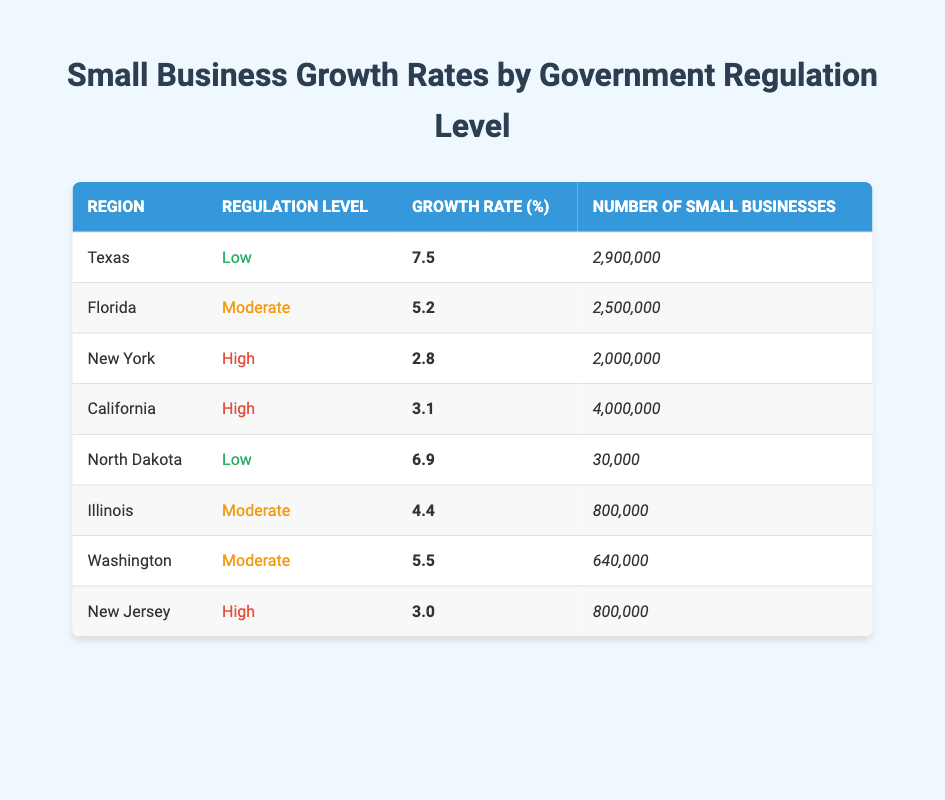What is the small business growth rate in Texas? According to the table, Texas has a small business growth rate of 7.5%. This value is explicitly stated in the row for Texas.
Answer: 7.5% Which region has the highest number of small businesses? By comparing the values in the "Number of Small Businesses" column, California has the highest number at 4,000,000.
Answer: California What is the average small business growth rate for regions with low government regulation? The growth rates for regions with low regulation are 7.5% (Texas) and 6.9% (North Dakota). To find the average, add these two values: 7.5 + 6.9 = 14.4%. Then, divide by 2 to find the average: 14.4 / 2 = 7.2%.
Answer: 7.2% Is the statement "Florida has a higher small business growth rate than New York" true? Florida has a growth rate of 5.2% and New York has a growth rate of 2.8%. Since 5.2% is greater than 2.8%, the statement is true.
Answer: Yes How many small businesses are in regions classified as having moderate government regulation? The regions with moderate regulation are Florida (2,500,000), Illinois (800,000), and Washington (640,000). Adding these numbers gives: 2,500,000 + 800,000 + 640,000 = 3,940,000.
Answer: 3,940,000 What is the difference in small business growth rates between Texas and New York? Texas has a growth rate of 7.5% and New York has a growth rate of 2.8%. To find the difference, subtract New York's rate from Texas's: 7.5 - 2.8 = 4.7%.
Answer: 4.7% Are there more small businesses in New Jersey compared to Illinois? New Jersey has 800,000 small businesses, and Illinois also has 800,000 small businesses. Since they are equal, the answer to the question is false.
Answer: No Which region has a growth rate closer to the median growth rate among all regions? To find the median, first list the growth rates in order: 2.8, 3.0, 3.1, 4.4, 5.2, 5.5, 6.9, 7.5. The median (the average of the 4th and 5th values) is (4.4 + 5.2) / 2 = 4.8%. The closest region to this median is Illinois with a growth rate of 4.4%.
Answer: Illinois 